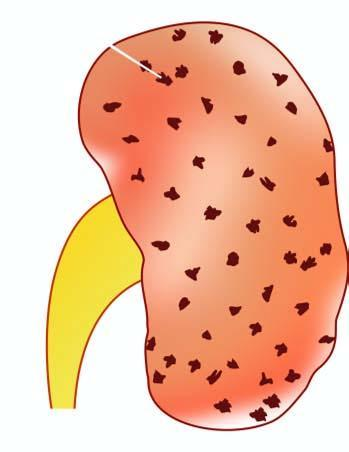s the kidney enlarged in size and weight?
Answer the question using a single word or phrase. Yes 